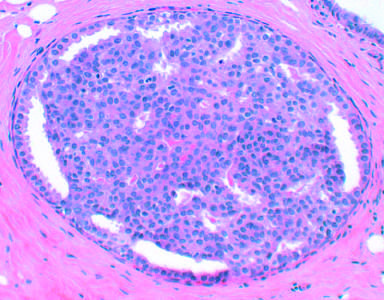s proliferative breast disease characterized by increased numbers of epithelial cells, as in this example of epithelial hyperplasia?
Answer the question using a single word or phrase. Yes 